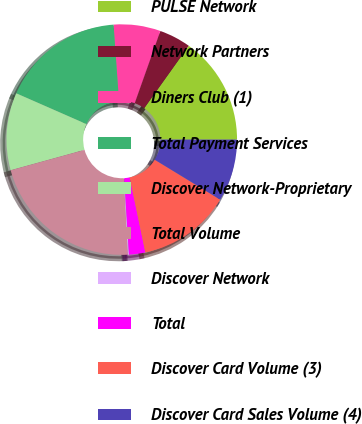Convert chart to OTSL. <chart><loc_0><loc_0><loc_500><loc_500><pie_chart><fcel>PULSE Network<fcel>Network Partners<fcel>Diners Club (1)<fcel>Total Payment Services<fcel>Discover Network-Proprietary<fcel>Total Volume<fcel>Discover Network<fcel>Total<fcel>Discover Card Volume (3)<fcel>Discover Card Sales Volume (4)<nl><fcel>15.14%<fcel>4.43%<fcel>6.57%<fcel>17.28%<fcel>10.86%<fcel>21.57%<fcel>0.14%<fcel>2.29%<fcel>13.0%<fcel>8.71%<nl></chart> 